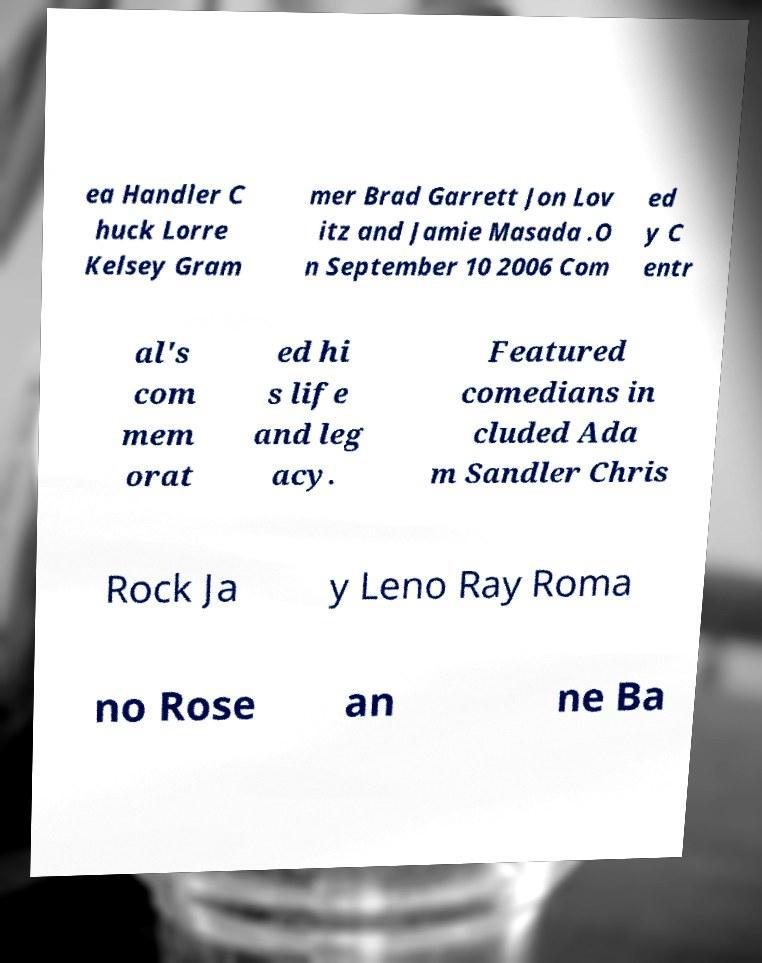There's text embedded in this image that I need extracted. Can you transcribe it verbatim? ea Handler C huck Lorre Kelsey Gram mer Brad Garrett Jon Lov itz and Jamie Masada .O n September 10 2006 Com ed y C entr al's com mem orat ed hi s life and leg acy. Featured comedians in cluded Ada m Sandler Chris Rock Ja y Leno Ray Roma no Rose an ne Ba 